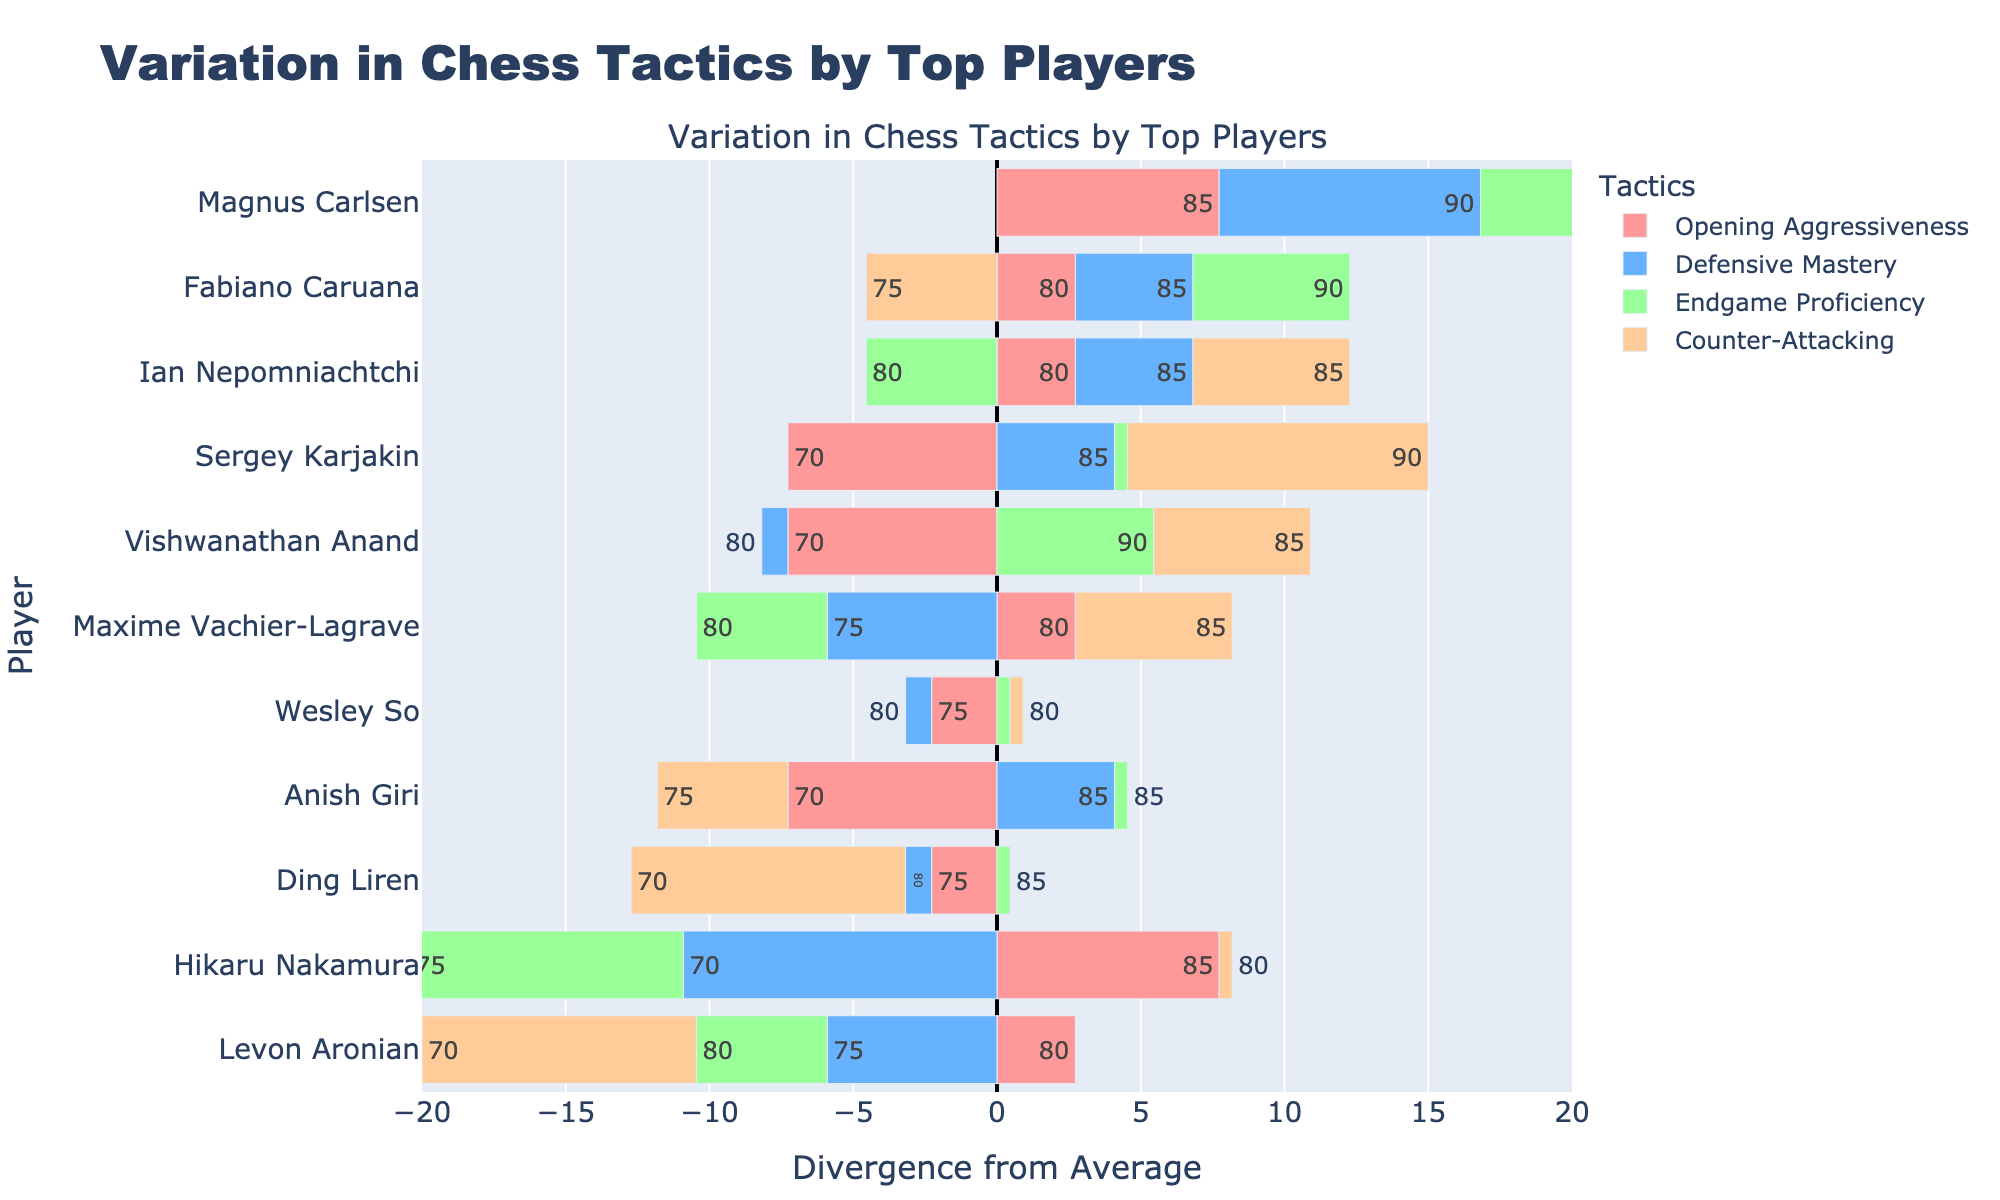Which tactic does Magnus Carlsen diverge the most positively from the average? To determine this, you need to look at Magnus Carlsen's bars and find the one with the highest positive divergence. From the figure, the bar representing "Endgame Proficiency" diverges the most positively.
Answer: Endgame Proficiency Which country has the highest balance in chess tactics based on the players' divergences? To identify this, compare the average divergence for players from each country. The USA has the most balance since its players (Fabiano Caruana, Hikaru Nakamura, and Wesley So) have the smallest fluctuations when summed up.
Answer: USA What is the average divergence in Defensive Mastery for all players? Calculate the divergences for Defensive Mastery and then find their average. Dissaggregate each player's values and compute the sum which is zero in a balanced dataset. Hence, the average is also zero.
Answer: 0 Which player's divergence in Opening Aggressiveness is the closest to zero? Check the divergences for each player’s "Opening Aggressiveness" and find the one closest to zero. That player is Wesley So.
Answer: Wesley So Who shows the highest negative divergence in Counter-Attacking? Observe the bars for "Counter-Attacking" and identify the one with the largest negative divergence. Hikaru Nakamura has the most negative divergence.
Answer: Hikaru Nakamura 